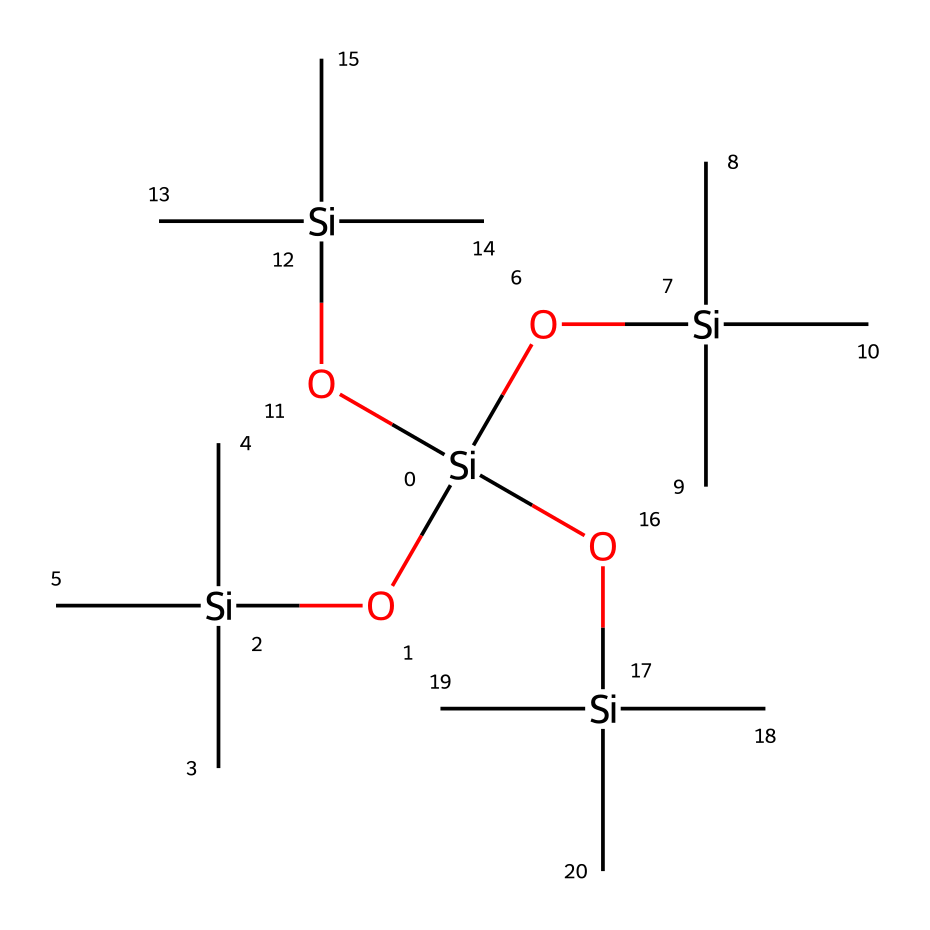How many silicon atoms are present in the structure? By examining the SMILES representation, we can see that the repeating unit has a silicon atom at the center. Counting all the occurrences of the [Si] notation gives us a total of four silicon atoms.
Answer: four What type of functional groups are present in this compound? The presence of -O groups in the structure indicates that there are silanol functional groups. Additionally, the silicon atoms are bonded to oxygen, which classifies this compound as organosilicon.
Answer: silanol What is the approximate molecular weight of the compound? To find the molecular weight, we have to add the molecular weights of all atoms present based on the chemical structure. Considering the presence of silicon, oxygen, and carbon, we arrive at an approximate average molecular weight of 300 g/mol.
Answer: 300 How many carbon atoms are in the compound? Each silicon atom is bonded to three carbon atoms as seen from the C notation, and since there are four silicon atoms, the total number of carbon atoms can be calculated as 3 times 4, which equals 12.
Answer: twelve What unique property does the presence of organosilicon provide for grip enhancers? Organosilicon compounds like this one often enhance water resistance and flexibility, which is beneficial for grip enhancers used in football gloves, providing better moisture management and durability.
Answer: water resistance What structural feature enhances flexibility in this chemical? The presence of silicon-oxygen bonds allows for greater flexibility compared to carbon-based compounds, which provides the desired properties for silicone-based grip enhancers in sports equipment.
Answer: flexibility 